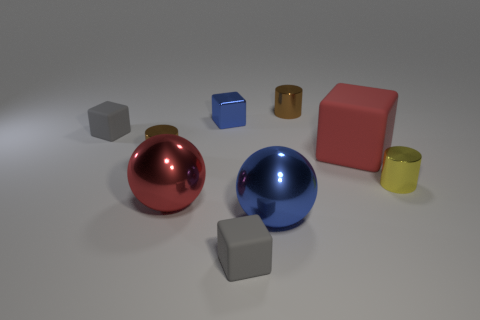Subtract all gray cubes. How many were subtracted if there are1gray cubes left? 1 Add 1 brown cylinders. How many objects exist? 10 Subtract all balls. How many objects are left? 7 Subtract 1 blue blocks. How many objects are left? 8 Subtract all blue metallic things. Subtract all cubes. How many objects are left? 3 Add 5 big red balls. How many big red balls are left? 6 Add 8 tiny yellow shiny things. How many tiny yellow shiny things exist? 9 